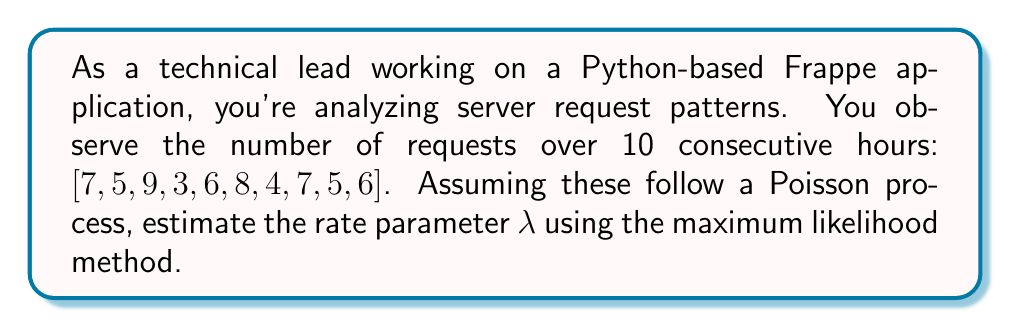Provide a solution to this math problem. To estimate the rate parameter $\lambda$ of a Poisson process using maximum likelihood:

1) The likelihood function for a Poisson process with $n$ observations $x_1, x_2, ..., x_n$ over time intervals $t_1, t_2, ..., t_n$ is:

   $$L(\lambda) = \prod_{i=1}^n \frac{e^{-\lambda t_i}(\lambda t_i)^{x_i}}{x_i!}$$

2) For our case, all time intervals are 1 hour, so $t_i = 1$ for all $i$. The log-likelihood function is:

   $$\ln L(\lambda) = \sum_{i=1}^n (x_i \ln \lambda - \lambda - \ln(x_i!))$$

3) To find the maximum likelihood estimator, we differentiate with respect to $\lambda$ and set to zero:

   $$\frac{d}{d\lambda} \ln L(\lambda) = \sum_{i=1}^n (\frac{x_i}{\lambda} - 1) = 0$$

4) Solving this equation:

   $$\sum_{i=1}^n x_i = n\lambda$$

   $$\lambda = \frac{1}{n} \sum_{i=1}^n x_i$$

5) For our data:
   $n = 10$
   $\sum_{i=1}^n x_i = 7 + 5 + 9 + 3 + 6 + 8 + 4 + 7 + 5 + 6 = 60$

6) Therefore, the maximum likelihood estimate for $\lambda$ is:

   $$\lambda = \frac{60}{10} = 6$$
Answer: $\lambda = 6$ requests/hour 